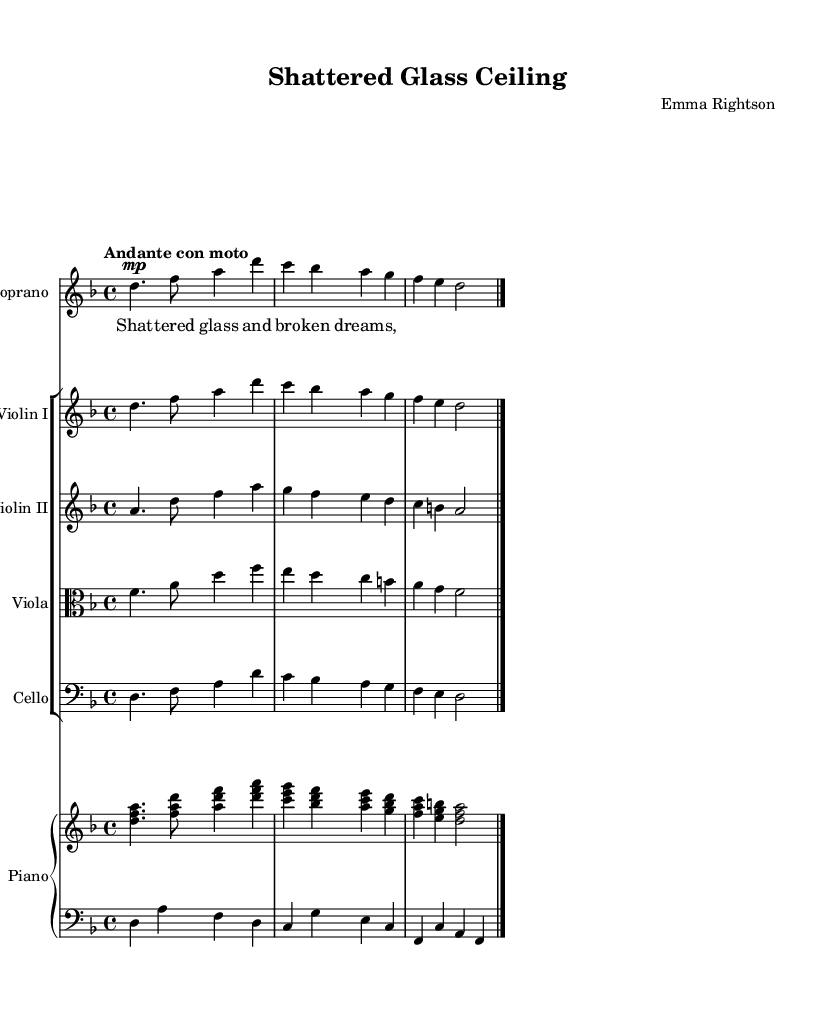what is the key signature of this music? The key signature is indicated by the sharps or flats at the beginning of the staff. In this case, the key signature has one flat, which corresponds to the key of D minor.
Answer: D minor what is the time signature of this music? The time signature is indicated by the numbers at the beginning of the staff. Here, it states "4/4," which means there are four beats in every measure and the quarter note gets one beat.
Answer: 4/4 what is the tempo marking for this piece? The tempo marking is featured above the staff and reads "Andante con moto," indicating a moderately slow tempo with some movement.
Answer: Andante con moto how many instruments are featured in this score? By counting the distinct staves and their groupings in the score, there are five instruments represented: Soprano, Violin I, Violin II, Viola, and Cello, along with Piano.
Answer: Five what is the first lyric of the soprano voice? The first lyric is found aligned with the notes in the soprano staff, which reads as "Shat."
Answer: Shat which instrument has the clef designation of 'alto'? The clef designation of 'alto' is indicated at the beginning of the viola staff, thus identifying it as the instrument using the alto clef.
Answer: Viola how many beats are in the first measure of the soprano voice? The first measure of the soprano voice, and all measures in 4/4 time, has four quarter-note beats, which sum up to four beats total.
Answer: Four 